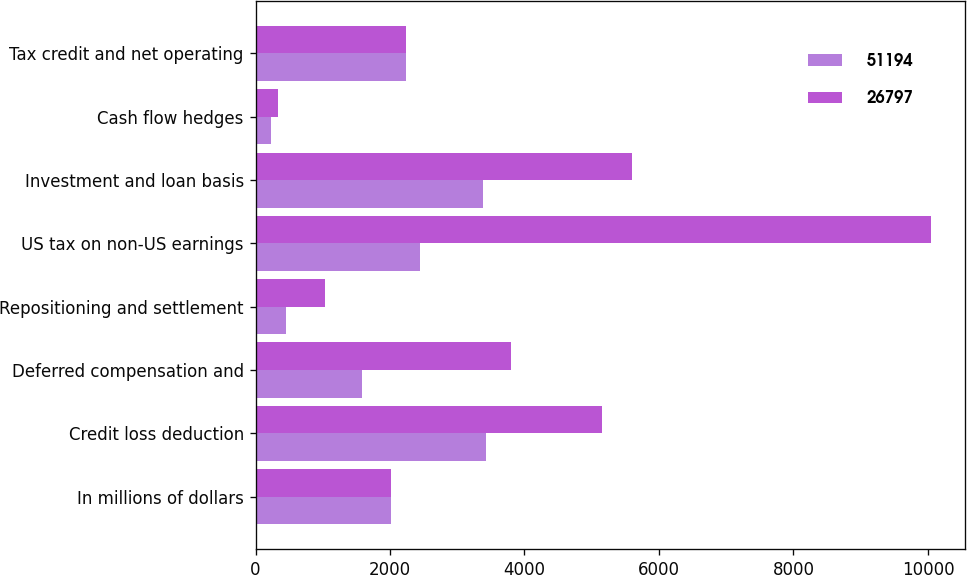<chart> <loc_0><loc_0><loc_500><loc_500><stacked_bar_chart><ecel><fcel>In millions of dollars<fcel>Credit loss deduction<fcel>Deferred compensation and<fcel>Repositioning and settlement<fcel>US tax on non-US earnings<fcel>Investment and loan basis<fcel>Cash flow hedges<fcel>Tax credit and net operating<nl><fcel>51194<fcel>2017<fcel>3423<fcel>1585<fcel>454<fcel>2452<fcel>3384<fcel>233<fcel>2234.5<nl><fcel>26797<fcel>2016<fcel>5146<fcel>3798<fcel>1033<fcel>10050<fcel>5594<fcel>327<fcel>2234.5<nl></chart> 